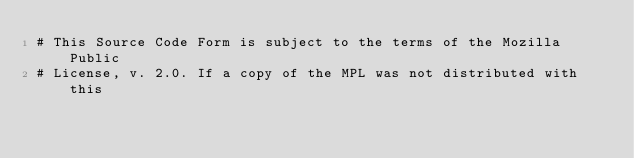<code> <loc_0><loc_0><loc_500><loc_500><_Python_># This Source Code Form is subject to the terms of the Mozilla Public
# License, v. 2.0. If a copy of the MPL was not distributed with this</code> 